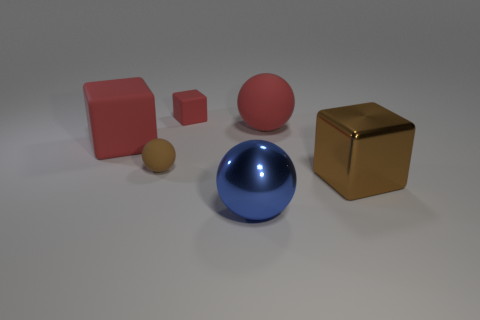Are there the same number of matte balls that are right of the red ball and large blue balls that are left of the brown rubber object?
Ensure brevity in your answer.  Yes. There is a big rubber object that is on the left side of the small brown sphere; is it the same shape as the brown object right of the shiny ball?
Make the answer very short. Yes. Is there any other thing that has the same shape as the large brown thing?
Keep it short and to the point. Yes. What is the shape of the tiny red object that is made of the same material as the small brown object?
Make the answer very short. Cube. Are there the same number of rubber objects right of the small brown rubber thing and tiny red rubber objects?
Give a very brief answer. No. Is the material of the big thing to the left of the blue thing the same as the brown object that is behind the big brown object?
Your answer should be very brief. Yes. The large brown metal thing in front of the brown thing that is to the left of the red matte sphere is what shape?
Ensure brevity in your answer.  Cube. What is the color of the large block that is made of the same material as the tiny block?
Offer a terse response. Red. Does the large metallic cube have the same color as the tiny ball?
Your answer should be very brief. Yes. What shape is the blue object that is the same size as the red rubber sphere?
Your response must be concise. Sphere. 